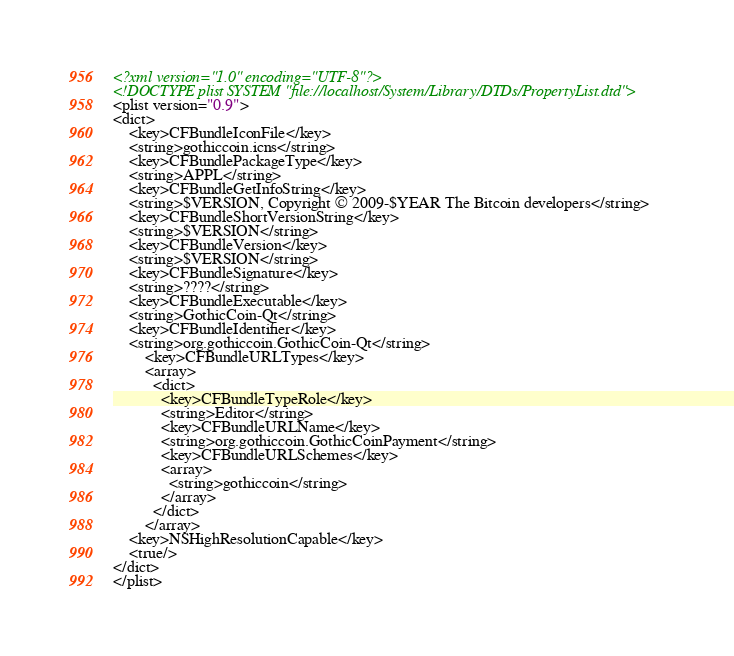Convert code to text. <code><loc_0><loc_0><loc_500><loc_500><_XML_><?xml version="1.0" encoding="UTF-8"?>
<!DOCTYPE plist SYSTEM "file://localhost/System/Library/DTDs/PropertyList.dtd">
<plist version="0.9">
<dict>
	<key>CFBundleIconFile</key>
	<string>gothiccoin.icns</string>
	<key>CFBundlePackageType</key>
	<string>APPL</string>
	<key>CFBundleGetInfoString</key>
	<string>$VERSION, Copyright © 2009-$YEAR The Bitcoin developers</string>
	<key>CFBundleShortVersionString</key>
	<string>$VERSION</string>
	<key>CFBundleVersion</key>
	<string>$VERSION</string>
	<key>CFBundleSignature</key>
	<string>????</string>
	<key>CFBundleExecutable</key>
	<string>GothicCoin-Qt</string>
	<key>CFBundleIdentifier</key>
	<string>org.gothiccoin.GothicCoin-Qt</string>
        <key>CFBundleURLTypes</key>
        <array>
          <dict>
            <key>CFBundleTypeRole</key>
            <string>Editor</string>
            <key>CFBundleURLName</key>
            <string>org.gothiccoin.GothicCoinPayment</string>
            <key>CFBundleURLSchemes</key>
            <array>
              <string>gothiccoin</string>
            </array>
          </dict>
        </array>
	<key>NSHighResolutionCapable</key>
	<true/>
</dict>
</plist>
</code> 